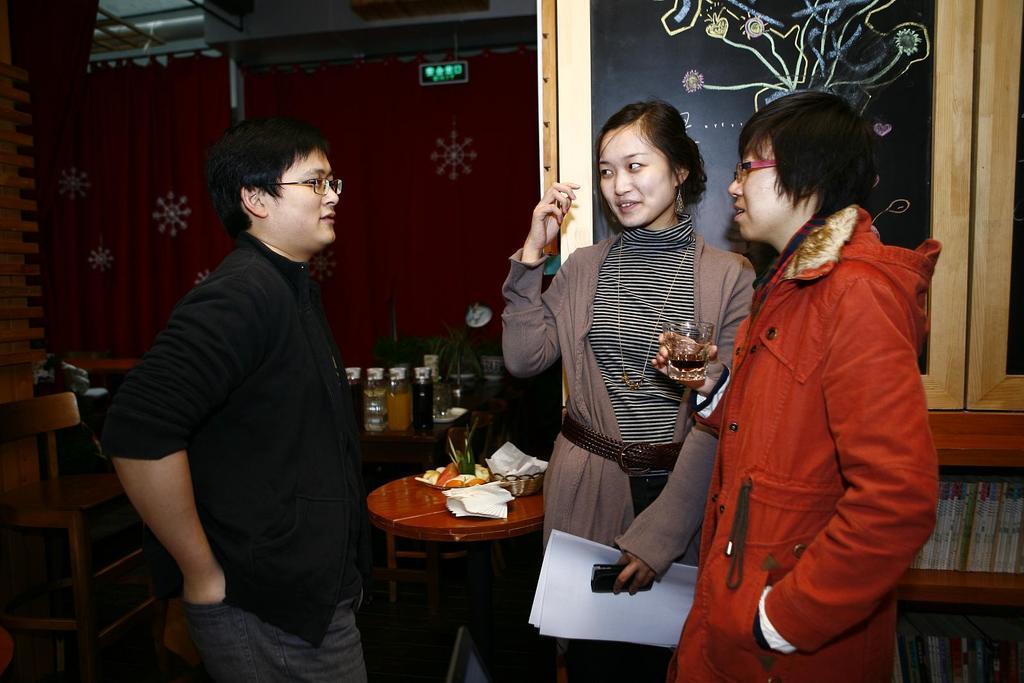In one or two sentences, can you explain what this image depicts? In this image I can see three people are standing. This is an inside view. At the back of these persons there are few tables on which few bottles, tissue papers and few bowls are placed. This person is holding a glass in hand and this person is holding a paper and mobile in her hand. 